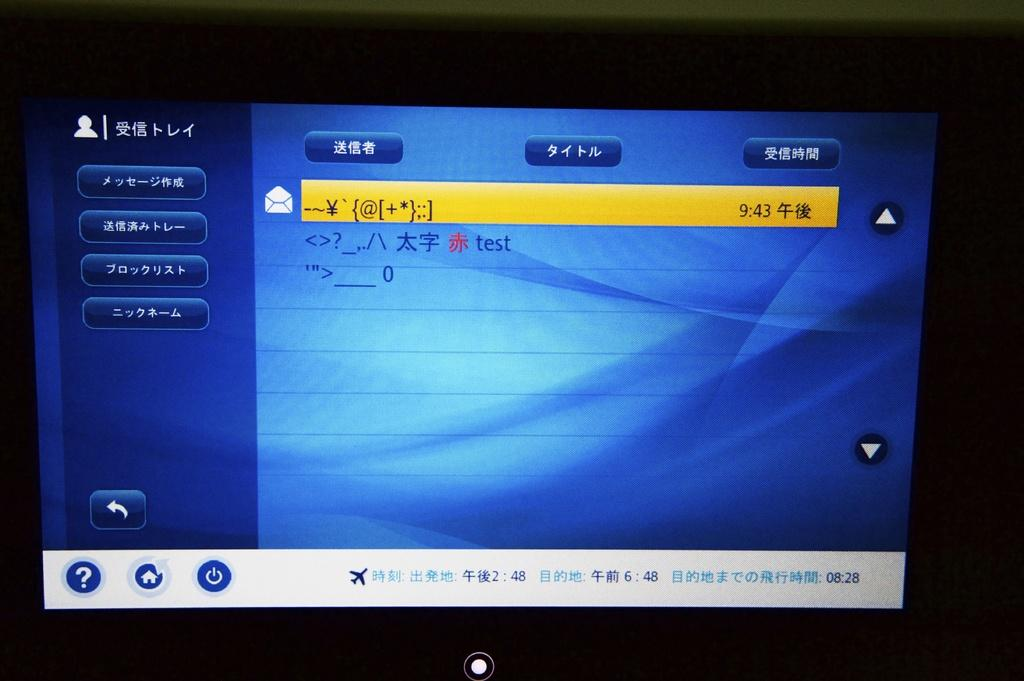Provide a one-sentence caption for the provided image. A blue tv screen with writing on it and the time 9:43 displayed in a yellow rectangle. 